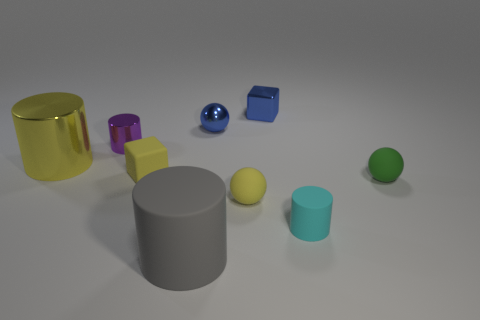How many other objects are the same size as the matte block?
Ensure brevity in your answer.  6. There is a tiny rubber ball to the left of the tiny cyan cylinder; does it have the same color as the matte block?
Provide a succinct answer. Yes. The large yellow object that is the same material as the tiny blue block is what shape?
Your answer should be compact. Cylinder. Is there a rubber thing on the left side of the small ball right of the tiny cyan thing?
Provide a short and direct response. Yes. How big is the yellow cylinder?
Keep it short and to the point. Large. How many things are either tiny yellow spheres or big red metallic balls?
Provide a short and direct response. 1. Is the material of the small cube that is in front of the small purple thing the same as the tiny cylinder on the left side of the yellow block?
Provide a succinct answer. No. What color is the big cylinder that is the same material as the blue cube?
Offer a very short reply. Yellow. How many matte objects are the same size as the yellow rubber cube?
Provide a short and direct response. 3. What number of other objects are the same color as the large matte cylinder?
Your response must be concise. 0. 